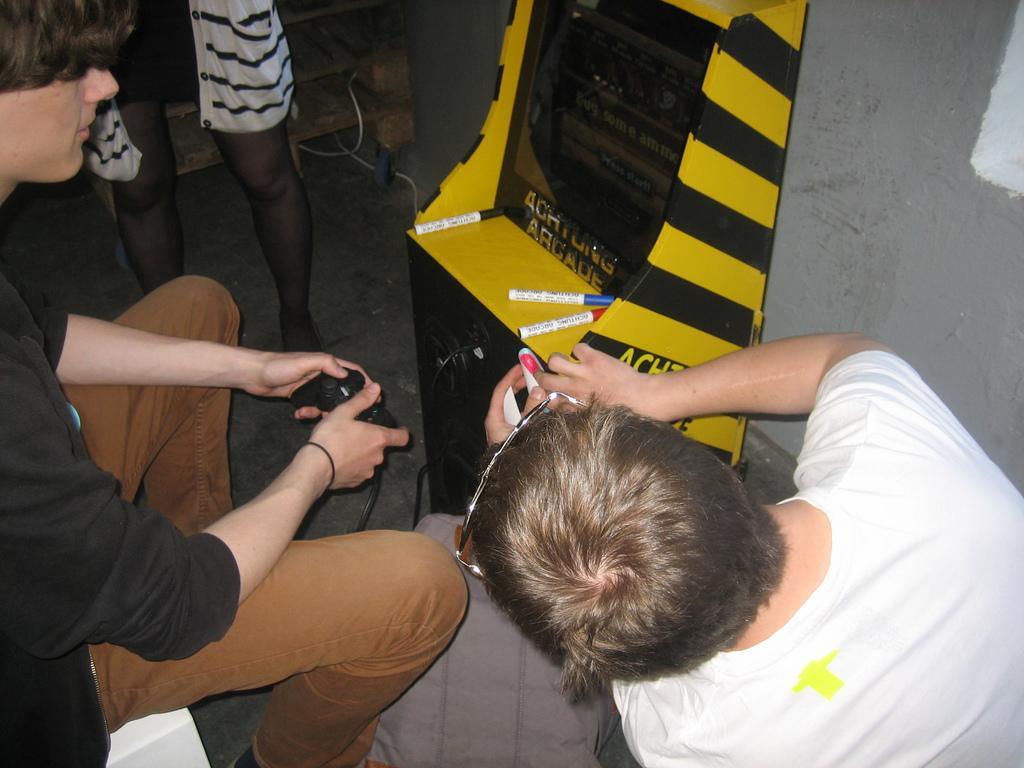Please provide a concise description of this image. In this image there are group of people, in the foreground there are two persons sitting and they are holding some objects it seems that they are playing video games. And in the center there is one board and some markers, in the background there is one person standing and also there are some wires and wooden table, and in the background there is wall. At the bottom there is a walkway. 